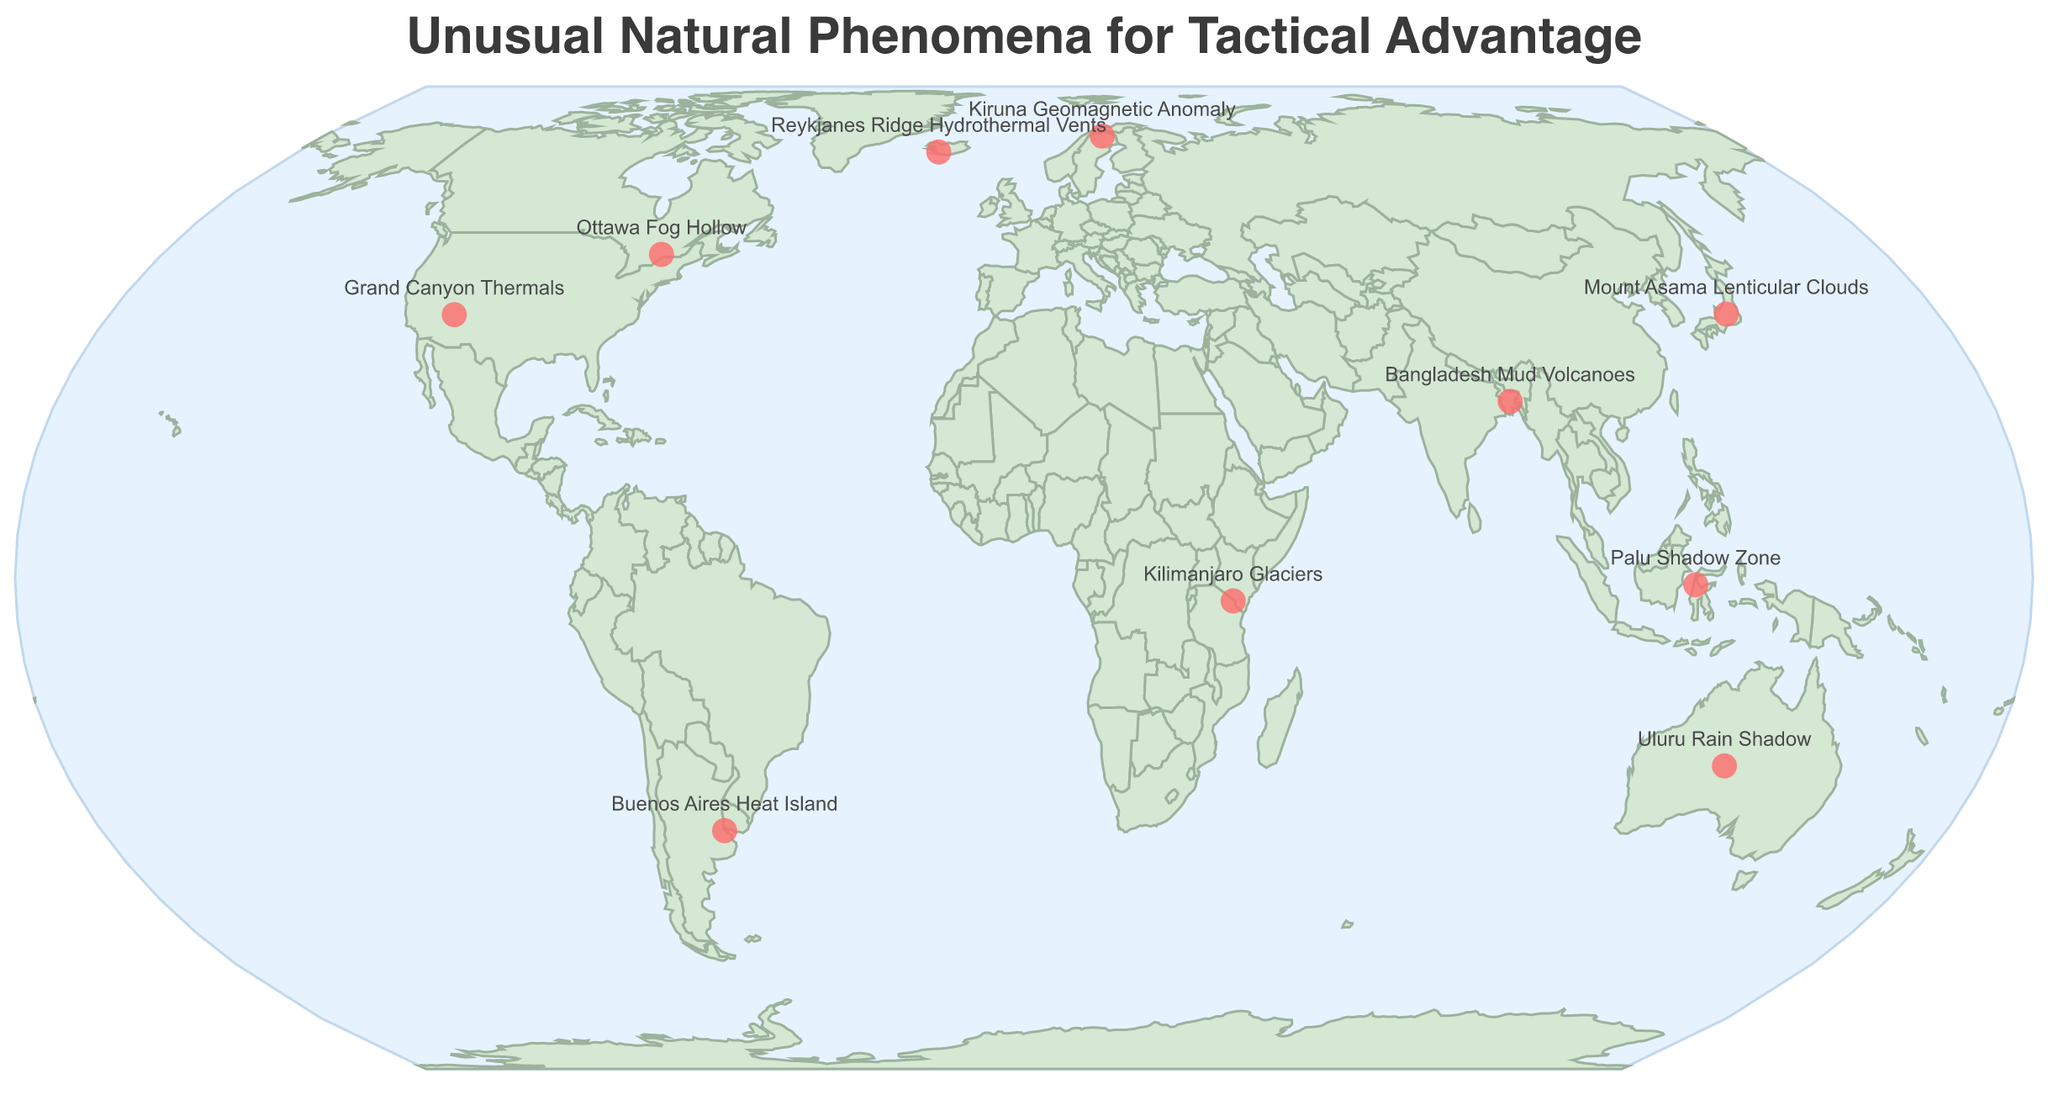Where is the Grand Canyon Thermals located on the map? The Grand Canyon Thermals are represented by a red circle on the map, located at approximately 36.1162 latitude and -112.0826 longitude.
Answer: Grand Canyon How many locations exhibit unusual natural phenomena in the Southern Hemisphere? By visually inspecting the map, identify which red circles (indicating unique phenomena) are situated south of the equator. There are four such points: Palu Shadow Zone, Kilimanjaro Glaciers, Buenos Aires Heat Island, and Uluru Rain Shadow.
Answer: 4 Which phenomenon could be leveraged for submarine concealment? Referring to the text labels near the red circles, the phenomenon at Reykjanes Ridge, described as "Reykjanes Ridge Hydrothermal Vents," aids in submarine concealment.
Answer: Reykjanes Ridge Hydrothermal Vents Which phenomenon offers a tactical advantage for visual cover during aerial operations? By checking the descriptions next to the phenomena, "Mount Asama Lenticular Clouds" is noted as providing visual cover for aerial operations.
Answer: Mount Asama Lenticular Clouds What is the latitude and longitude of the phenomenon that interferes with navigation systems? The "Kiruna Geomagnetic Anomaly" interferes with navigation systems, located at approximately 67.8462 latitude and 20.1087 longitude.
Answer: 67.8462, 20.1087 Compare the tactical advantage offered by the Palu Shadow Zone with the one provided by the Buenos Aires Heat Island. The Palu Shadow Zone provides a radio signal dead zone useful for communication disruption, while the Buenos Aires Heat Island helps in masking thermal signatures. Both have unique advantages for different types of covert operations.
Answer: Different tactical advantages Which phenomenon is situated closest to the equator? Assess the latitude values of the phenomena listed near the equator. The "Palu Shadow Zone" at -0.9167 latitude is closest.
Answer: Palu Shadow Zone Which two phenomena are found at higher altitudes and could provide specific high-altitude tactical advantages? Based on the phenomenon descriptions, "Kilimanjaro Glaciers" are high-altitude and provide a water source, while "Mount Asama Lenticular Clouds" can offer visual cover in aerial operations.
Answer: Kilimanjaro Glaciers, Mount Asama Lenticular Clouds 